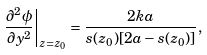<formula> <loc_0><loc_0><loc_500><loc_500>\left . \frac { \partial ^ { 2 } \phi } { \partial y ^ { 2 } } \right | _ { z = z _ { 0 } } = \frac { 2 k a } { s ( z _ { 0 } ) [ 2 a - s ( z _ { 0 } ) ] } ,</formula> 